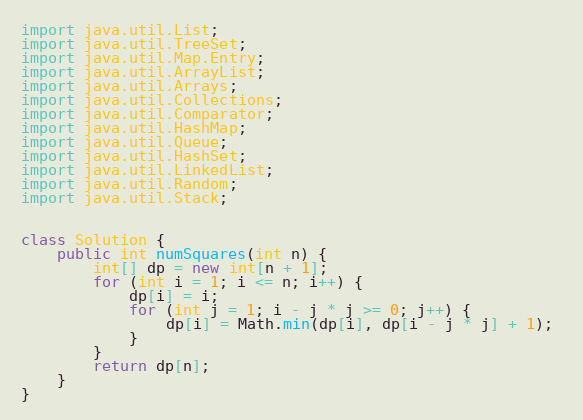Convert code to text. <code><loc_0><loc_0><loc_500><loc_500><_Java_>
import java.util.List;
import java.util.TreeSet;
import java.util.Map.Entry;
import java.util.ArrayList;
import java.util.Arrays;
import java.util.Collections;
import java.util.Comparator;
import java.util.HashMap;
import java.util.Queue;
import java.util.HashSet;
import java.util.LinkedList;
import java.util.Random;
import java.util.Stack;


class Solution {
    public int numSquares(int n) {
        int[] dp = new int[n + 1]; 
        for (int i = 1; i <= n; i++) {
            dp[i] = i; 
            for (int j = 1; i - j * j >= 0; j++) { 
                dp[i] = Math.min(dp[i], dp[i - j * j] + 1); 
            }
        }
        return dp[n];
    }
}

</code> 